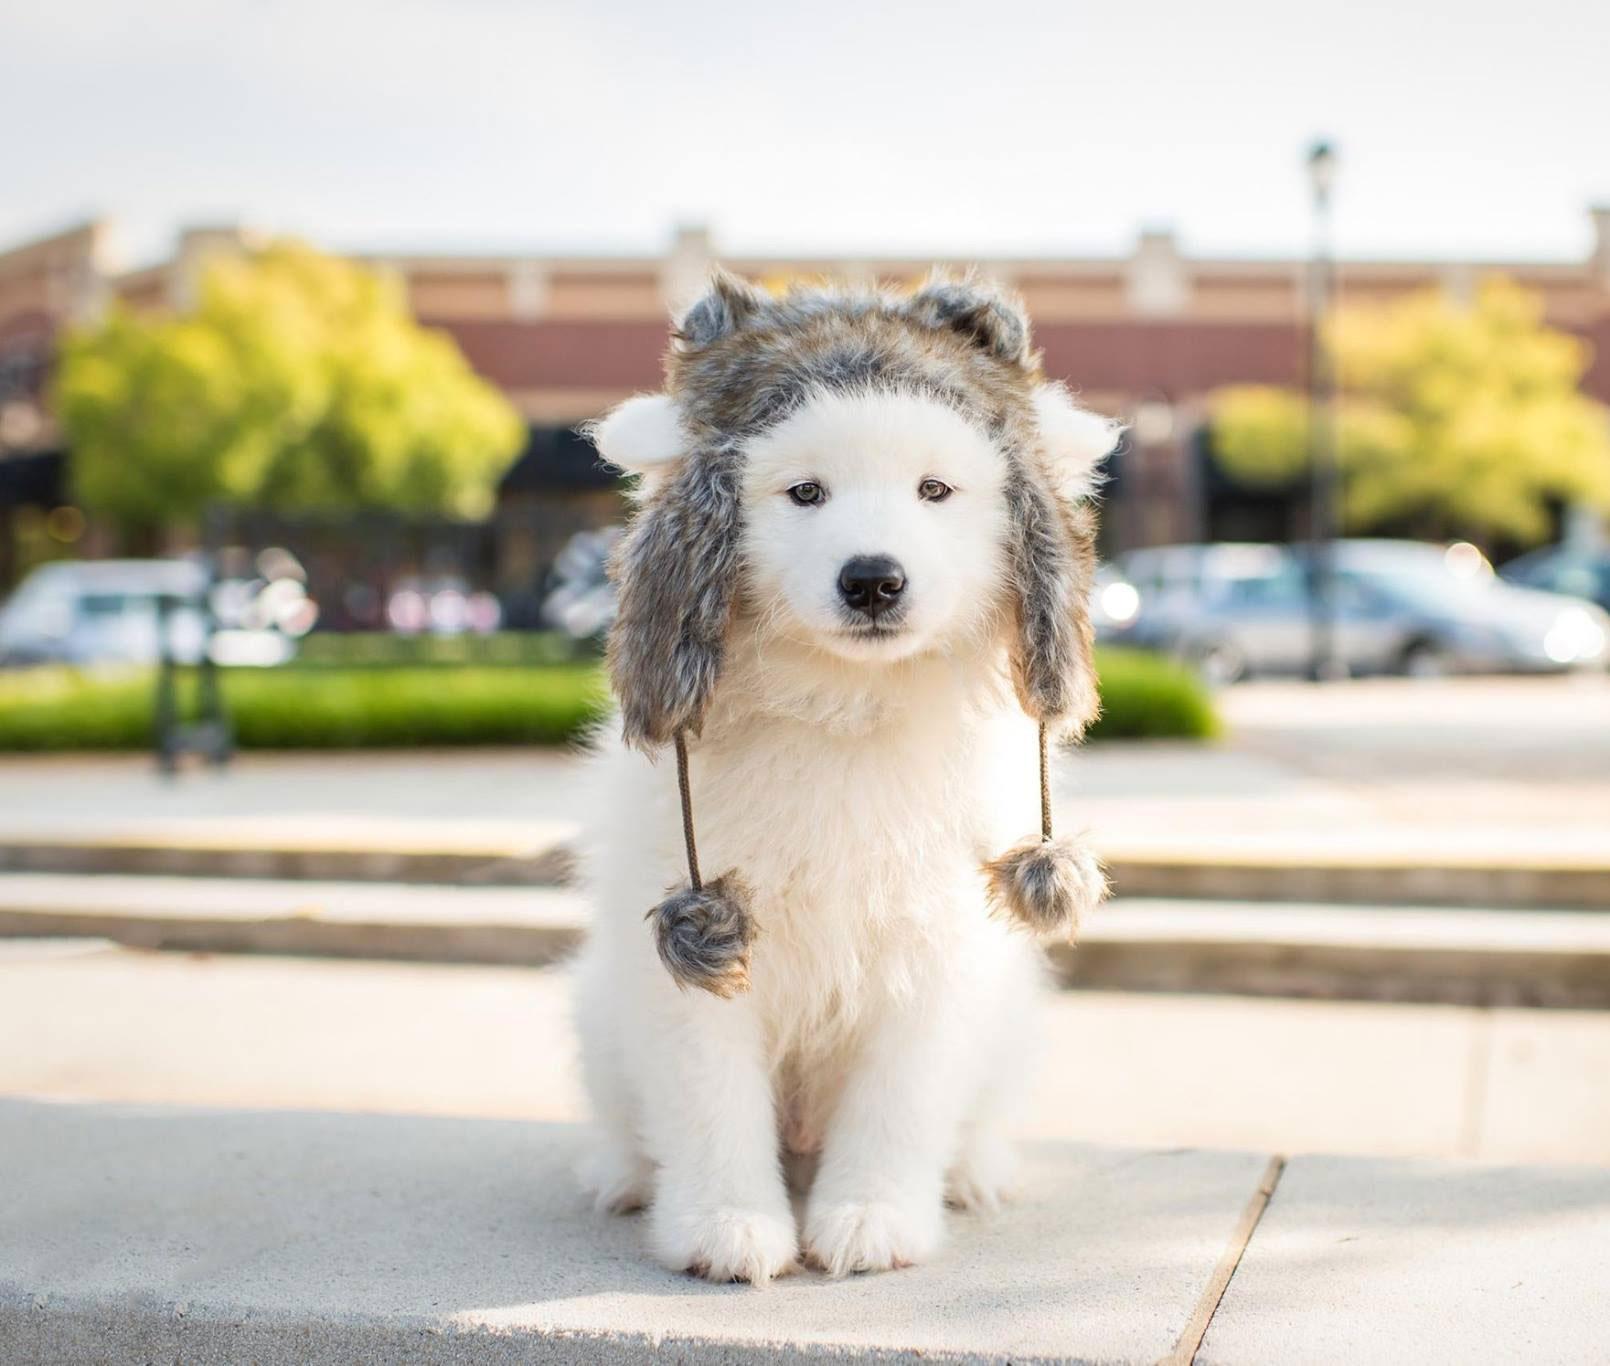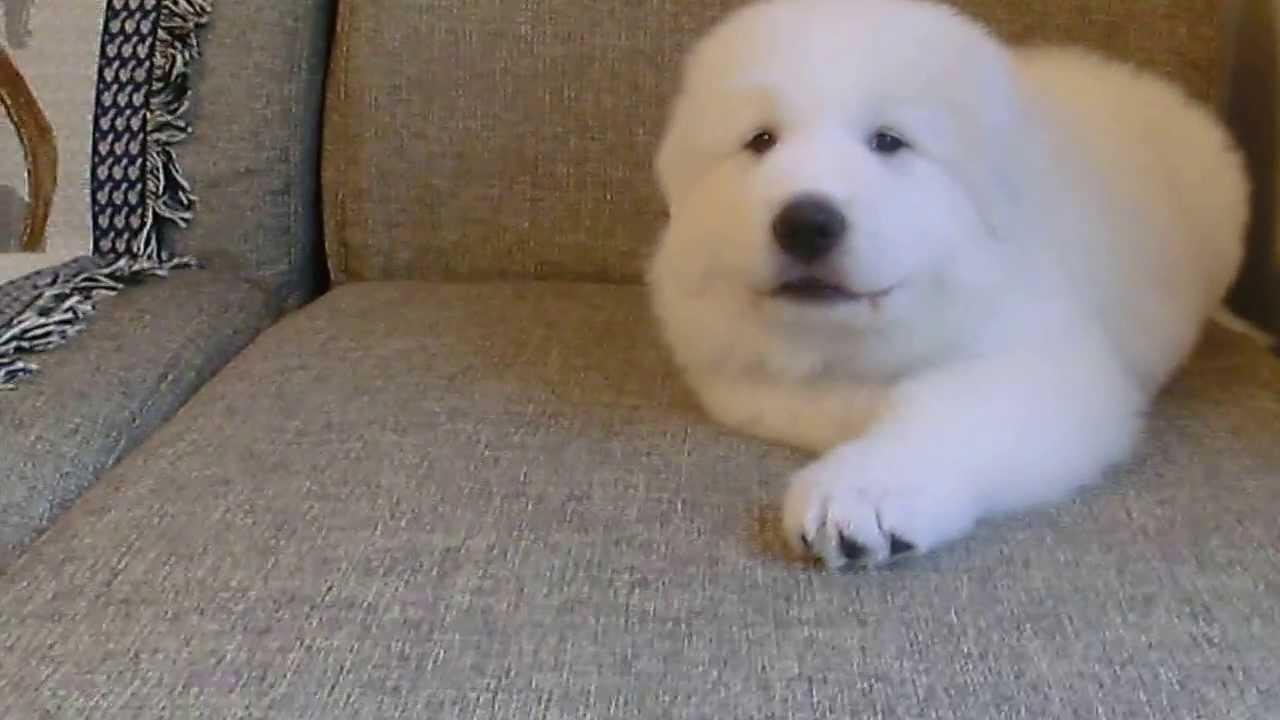The first image is the image on the left, the second image is the image on the right. Analyze the images presented: Is the assertion "In total, only two fluffy dogs can be seen in these images." valid? Answer yes or no. Yes. The first image is the image on the left, the second image is the image on the right. For the images shown, is this caption "There are two dogs" true? Answer yes or no. Yes. 